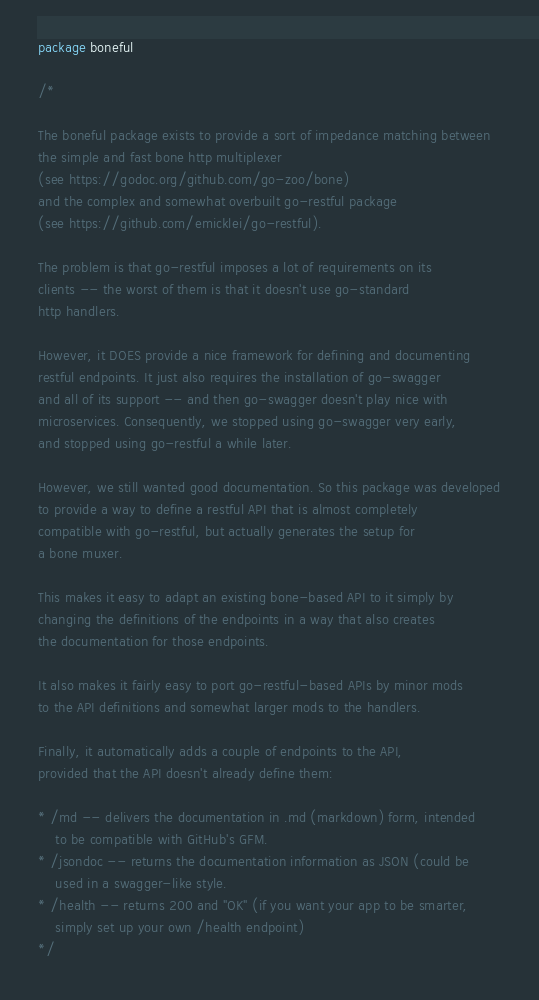<code> <loc_0><loc_0><loc_500><loc_500><_Go_>package boneful

/*

The boneful package exists to provide a sort of impedance matching between
the simple and fast bone http multiplexer
(see https://godoc.org/github.com/go-zoo/bone)
and the complex and somewhat overbuilt go-restful package
(see https://github.com/emicklei/go-restful).

The problem is that go-restful imposes a lot of requirements on its
clients -- the worst of them is that it doesn't use go-standard
http handlers.

However, it DOES provide a nice framework for defining and documenting
restful endpoints. It just also requires the installation of go-swagger
and all of its support -- and then go-swagger doesn't play nice with
microservices. Consequently, we stopped using go-swagger very early,
and stopped using go-restful a while later.

However, we still wanted good documentation. So this package was developed
to provide a way to define a restful API that is almost completely
compatible with go-restful, but actually generates the setup for
a bone muxer.

This makes it easy to adapt an existing bone-based API to it simply by
changing the definitions of the endpoints in a way that also creates
the documentation for those endpoints.

It also makes it fairly easy to port go-restful-based APIs by minor mods
to the API definitions and somewhat larger mods to the handlers.

Finally, it automatically adds a couple of endpoints to the API,
provided that the API doesn't already define them:

* /md -- delivers the documentation in .md (markdown) form, intended
	to be compatible with GitHub's GFM.
* /jsondoc -- returns the documentation information as JSON (could be
	used in a swagger-like style.
* /health -- returns 200 and "OK" (if you want your app to be smarter,
	simply set up your own /health endpoint)
*/
</code> 